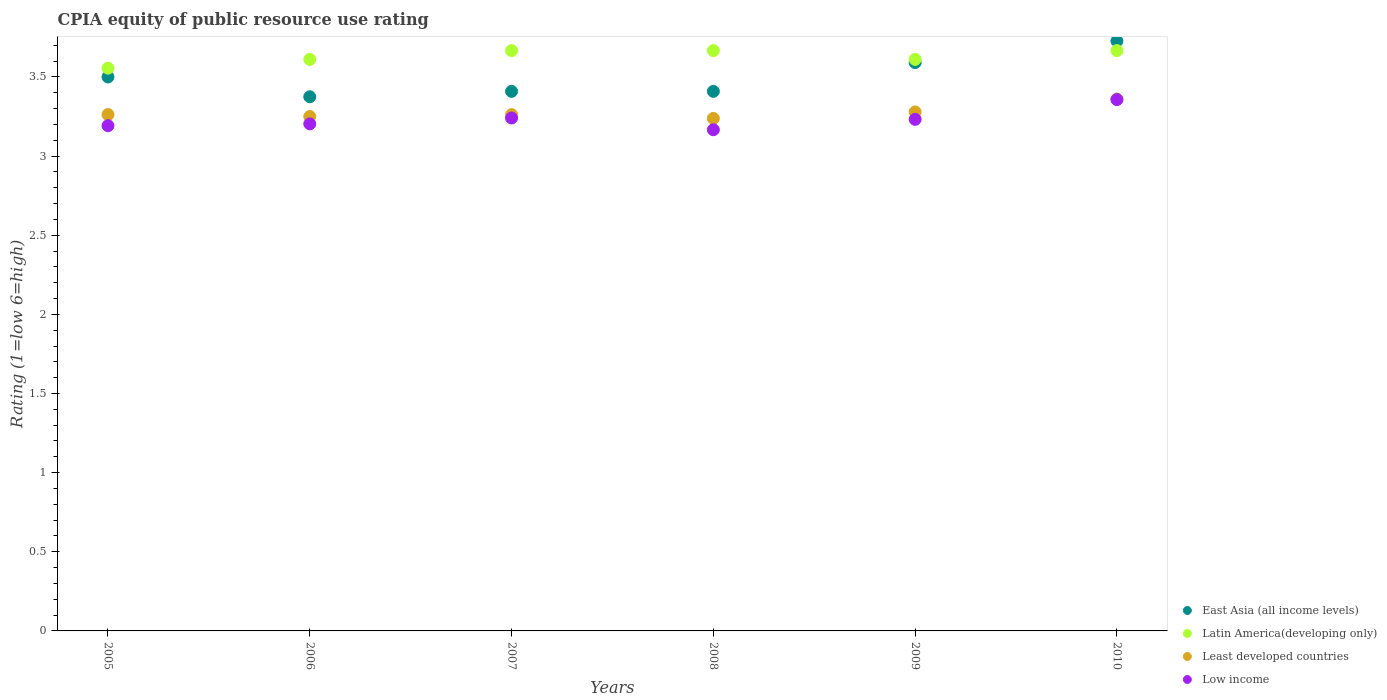How many different coloured dotlines are there?
Make the answer very short. 4. Is the number of dotlines equal to the number of legend labels?
Ensure brevity in your answer.  Yes. What is the CPIA rating in East Asia (all income levels) in 2006?
Provide a short and direct response. 3.38. Across all years, what is the maximum CPIA rating in East Asia (all income levels)?
Offer a very short reply. 3.73. Across all years, what is the minimum CPIA rating in Latin America(developing only)?
Ensure brevity in your answer.  3.56. What is the total CPIA rating in Least developed countries in the graph?
Provide a succinct answer. 19.65. What is the difference between the CPIA rating in Low income in 2006 and that in 2010?
Your answer should be very brief. -0.15. What is the difference between the CPIA rating in Low income in 2009 and the CPIA rating in East Asia (all income levels) in 2008?
Your response must be concise. -0.18. What is the average CPIA rating in East Asia (all income levels) per year?
Your answer should be very brief. 3.5. In the year 2007, what is the difference between the CPIA rating in Least developed countries and CPIA rating in Latin America(developing only)?
Offer a terse response. -0.4. In how many years, is the CPIA rating in East Asia (all income levels) greater than 1.3?
Make the answer very short. 6. What is the ratio of the CPIA rating in East Asia (all income levels) in 2006 to that in 2009?
Provide a short and direct response. 0.94. What is the difference between the highest and the second highest CPIA rating in Latin America(developing only)?
Make the answer very short. 0. What is the difference between the highest and the lowest CPIA rating in Least developed countries?
Provide a short and direct response. 0.12. Is it the case that in every year, the sum of the CPIA rating in East Asia (all income levels) and CPIA rating in Least developed countries  is greater than the CPIA rating in Low income?
Give a very brief answer. Yes. Is the CPIA rating in Least developed countries strictly greater than the CPIA rating in East Asia (all income levels) over the years?
Keep it short and to the point. No. What is the difference between two consecutive major ticks on the Y-axis?
Offer a very short reply. 0.5. Does the graph contain any zero values?
Your answer should be very brief. No. Does the graph contain grids?
Keep it short and to the point. No. Where does the legend appear in the graph?
Make the answer very short. Bottom right. How many legend labels are there?
Offer a very short reply. 4. How are the legend labels stacked?
Your answer should be compact. Vertical. What is the title of the graph?
Offer a very short reply. CPIA equity of public resource use rating. Does "Guinea-Bissau" appear as one of the legend labels in the graph?
Make the answer very short. No. What is the Rating (1=low 6=high) of East Asia (all income levels) in 2005?
Make the answer very short. 3.5. What is the Rating (1=low 6=high) in Latin America(developing only) in 2005?
Offer a very short reply. 3.56. What is the Rating (1=low 6=high) of Least developed countries in 2005?
Your answer should be compact. 3.26. What is the Rating (1=low 6=high) of Low income in 2005?
Your answer should be compact. 3.19. What is the Rating (1=low 6=high) of East Asia (all income levels) in 2006?
Keep it short and to the point. 3.38. What is the Rating (1=low 6=high) in Latin America(developing only) in 2006?
Provide a succinct answer. 3.61. What is the Rating (1=low 6=high) in Low income in 2006?
Give a very brief answer. 3.2. What is the Rating (1=low 6=high) of East Asia (all income levels) in 2007?
Your answer should be very brief. 3.41. What is the Rating (1=low 6=high) in Latin America(developing only) in 2007?
Provide a succinct answer. 3.67. What is the Rating (1=low 6=high) in Least developed countries in 2007?
Provide a succinct answer. 3.26. What is the Rating (1=low 6=high) of Low income in 2007?
Keep it short and to the point. 3.24. What is the Rating (1=low 6=high) of East Asia (all income levels) in 2008?
Provide a short and direct response. 3.41. What is the Rating (1=low 6=high) in Latin America(developing only) in 2008?
Your response must be concise. 3.67. What is the Rating (1=low 6=high) of Least developed countries in 2008?
Make the answer very short. 3.24. What is the Rating (1=low 6=high) in Low income in 2008?
Offer a terse response. 3.17. What is the Rating (1=low 6=high) in East Asia (all income levels) in 2009?
Give a very brief answer. 3.59. What is the Rating (1=low 6=high) in Latin America(developing only) in 2009?
Ensure brevity in your answer.  3.61. What is the Rating (1=low 6=high) of Least developed countries in 2009?
Offer a terse response. 3.28. What is the Rating (1=low 6=high) of Low income in 2009?
Keep it short and to the point. 3.23. What is the Rating (1=low 6=high) in East Asia (all income levels) in 2010?
Ensure brevity in your answer.  3.73. What is the Rating (1=low 6=high) in Latin America(developing only) in 2010?
Make the answer very short. 3.67. What is the Rating (1=low 6=high) of Least developed countries in 2010?
Your answer should be compact. 3.36. What is the Rating (1=low 6=high) of Low income in 2010?
Keep it short and to the point. 3.36. Across all years, what is the maximum Rating (1=low 6=high) in East Asia (all income levels)?
Provide a short and direct response. 3.73. Across all years, what is the maximum Rating (1=low 6=high) in Latin America(developing only)?
Offer a terse response. 3.67. Across all years, what is the maximum Rating (1=low 6=high) of Least developed countries?
Provide a succinct answer. 3.36. Across all years, what is the maximum Rating (1=low 6=high) in Low income?
Ensure brevity in your answer.  3.36. Across all years, what is the minimum Rating (1=low 6=high) of East Asia (all income levels)?
Offer a terse response. 3.38. Across all years, what is the minimum Rating (1=low 6=high) in Latin America(developing only)?
Give a very brief answer. 3.56. Across all years, what is the minimum Rating (1=low 6=high) of Least developed countries?
Ensure brevity in your answer.  3.24. Across all years, what is the minimum Rating (1=low 6=high) of Low income?
Make the answer very short. 3.17. What is the total Rating (1=low 6=high) of East Asia (all income levels) in the graph?
Provide a short and direct response. 21.01. What is the total Rating (1=low 6=high) of Latin America(developing only) in the graph?
Your answer should be compact. 21.78. What is the total Rating (1=low 6=high) in Least developed countries in the graph?
Your answer should be compact. 19.65. What is the total Rating (1=low 6=high) of Low income in the graph?
Provide a succinct answer. 19.39. What is the difference between the Rating (1=low 6=high) of Latin America(developing only) in 2005 and that in 2006?
Your response must be concise. -0.06. What is the difference between the Rating (1=low 6=high) of Least developed countries in 2005 and that in 2006?
Offer a very short reply. 0.01. What is the difference between the Rating (1=low 6=high) in Low income in 2005 and that in 2006?
Provide a short and direct response. -0.01. What is the difference between the Rating (1=low 6=high) of East Asia (all income levels) in 2005 and that in 2007?
Your response must be concise. 0.09. What is the difference between the Rating (1=low 6=high) in Latin America(developing only) in 2005 and that in 2007?
Your answer should be very brief. -0.11. What is the difference between the Rating (1=low 6=high) in Least developed countries in 2005 and that in 2007?
Offer a very short reply. 0. What is the difference between the Rating (1=low 6=high) of Low income in 2005 and that in 2007?
Give a very brief answer. -0.05. What is the difference between the Rating (1=low 6=high) in East Asia (all income levels) in 2005 and that in 2008?
Keep it short and to the point. 0.09. What is the difference between the Rating (1=low 6=high) of Latin America(developing only) in 2005 and that in 2008?
Ensure brevity in your answer.  -0.11. What is the difference between the Rating (1=low 6=high) in Least developed countries in 2005 and that in 2008?
Provide a short and direct response. 0.02. What is the difference between the Rating (1=low 6=high) in Low income in 2005 and that in 2008?
Your response must be concise. 0.03. What is the difference between the Rating (1=low 6=high) in East Asia (all income levels) in 2005 and that in 2009?
Offer a very short reply. -0.09. What is the difference between the Rating (1=low 6=high) of Latin America(developing only) in 2005 and that in 2009?
Ensure brevity in your answer.  -0.06. What is the difference between the Rating (1=low 6=high) in Least developed countries in 2005 and that in 2009?
Ensure brevity in your answer.  -0.02. What is the difference between the Rating (1=low 6=high) of Low income in 2005 and that in 2009?
Your response must be concise. -0.04. What is the difference between the Rating (1=low 6=high) of East Asia (all income levels) in 2005 and that in 2010?
Your answer should be compact. -0.23. What is the difference between the Rating (1=low 6=high) in Latin America(developing only) in 2005 and that in 2010?
Offer a very short reply. -0.11. What is the difference between the Rating (1=low 6=high) in Least developed countries in 2005 and that in 2010?
Provide a short and direct response. -0.1. What is the difference between the Rating (1=low 6=high) in Low income in 2005 and that in 2010?
Your answer should be compact. -0.16. What is the difference between the Rating (1=low 6=high) in East Asia (all income levels) in 2006 and that in 2007?
Your response must be concise. -0.03. What is the difference between the Rating (1=low 6=high) in Latin America(developing only) in 2006 and that in 2007?
Your response must be concise. -0.06. What is the difference between the Rating (1=low 6=high) of Least developed countries in 2006 and that in 2007?
Your response must be concise. -0.01. What is the difference between the Rating (1=low 6=high) of Low income in 2006 and that in 2007?
Make the answer very short. -0.04. What is the difference between the Rating (1=low 6=high) in East Asia (all income levels) in 2006 and that in 2008?
Offer a terse response. -0.03. What is the difference between the Rating (1=low 6=high) in Latin America(developing only) in 2006 and that in 2008?
Keep it short and to the point. -0.06. What is the difference between the Rating (1=low 6=high) in Least developed countries in 2006 and that in 2008?
Offer a very short reply. 0.01. What is the difference between the Rating (1=low 6=high) in Low income in 2006 and that in 2008?
Your answer should be very brief. 0.04. What is the difference between the Rating (1=low 6=high) in East Asia (all income levels) in 2006 and that in 2009?
Offer a very short reply. -0.22. What is the difference between the Rating (1=low 6=high) of Least developed countries in 2006 and that in 2009?
Offer a very short reply. -0.03. What is the difference between the Rating (1=low 6=high) of Low income in 2006 and that in 2009?
Offer a very short reply. -0.03. What is the difference between the Rating (1=low 6=high) of East Asia (all income levels) in 2006 and that in 2010?
Offer a very short reply. -0.35. What is the difference between the Rating (1=low 6=high) of Latin America(developing only) in 2006 and that in 2010?
Your answer should be very brief. -0.06. What is the difference between the Rating (1=low 6=high) of Least developed countries in 2006 and that in 2010?
Ensure brevity in your answer.  -0.11. What is the difference between the Rating (1=low 6=high) in Low income in 2006 and that in 2010?
Your answer should be compact. -0.15. What is the difference between the Rating (1=low 6=high) in Least developed countries in 2007 and that in 2008?
Keep it short and to the point. 0.02. What is the difference between the Rating (1=low 6=high) in Low income in 2007 and that in 2008?
Provide a succinct answer. 0.07. What is the difference between the Rating (1=low 6=high) in East Asia (all income levels) in 2007 and that in 2009?
Your answer should be very brief. -0.18. What is the difference between the Rating (1=low 6=high) of Latin America(developing only) in 2007 and that in 2009?
Make the answer very short. 0.06. What is the difference between the Rating (1=low 6=high) of Least developed countries in 2007 and that in 2009?
Offer a very short reply. -0.02. What is the difference between the Rating (1=low 6=high) of Low income in 2007 and that in 2009?
Provide a short and direct response. 0.01. What is the difference between the Rating (1=low 6=high) of East Asia (all income levels) in 2007 and that in 2010?
Make the answer very short. -0.32. What is the difference between the Rating (1=low 6=high) of Least developed countries in 2007 and that in 2010?
Offer a very short reply. -0.1. What is the difference between the Rating (1=low 6=high) of Low income in 2007 and that in 2010?
Make the answer very short. -0.12. What is the difference between the Rating (1=low 6=high) of East Asia (all income levels) in 2008 and that in 2009?
Your answer should be compact. -0.18. What is the difference between the Rating (1=low 6=high) of Latin America(developing only) in 2008 and that in 2009?
Make the answer very short. 0.06. What is the difference between the Rating (1=low 6=high) in Least developed countries in 2008 and that in 2009?
Your response must be concise. -0.04. What is the difference between the Rating (1=low 6=high) in Low income in 2008 and that in 2009?
Make the answer very short. -0.07. What is the difference between the Rating (1=low 6=high) in East Asia (all income levels) in 2008 and that in 2010?
Ensure brevity in your answer.  -0.32. What is the difference between the Rating (1=low 6=high) of Latin America(developing only) in 2008 and that in 2010?
Ensure brevity in your answer.  0. What is the difference between the Rating (1=low 6=high) in Least developed countries in 2008 and that in 2010?
Offer a terse response. -0.12. What is the difference between the Rating (1=low 6=high) in Low income in 2008 and that in 2010?
Ensure brevity in your answer.  -0.19. What is the difference between the Rating (1=low 6=high) of East Asia (all income levels) in 2009 and that in 2010?
Ensure brevity in your answer.  -0.14. What is the difference between the Rating (1=low 6=high) of Latin America(developing only) in 2009 and that in 2010?
Provide a short and direct response. -0.06. What is the difference between the Rating (1=low 6=high) in Least developed countries in 2009 and that in 2010?
Provide a succinct answer. -0.08. What is the difference between the Rating (1=low 6=high) of Low income in 2009 and that in 2010?
Your response must be concise. -0.12. What is the difference between the Rating (1=low 6=high) of East Asia (all income levels) in 2005 and the Rating (1=low 6=high) of Latin America(developing only) in 2006?
Your answer should be compact. -0.11. What is the difference between the Rating (1=low 6=high) of East Asia (all income levels) in 2005 and the Rating (1=low 6=high) of Low income in 2006?
Ensure brevity in your answer.  0.3. What is the difference between the Rating (1=low 6=high) of Latin America(developing only) in 2005 and the Rating (1=low 6=high) of Least developed countries in 2006?
Ensure brevity in your answer.  0.31. What is the difference between the Rating (1=low 6=high) in Latin America(developing only) in 2005 and the Rating (1=low 6=high) in Low income in 2006?
Make the answer very short. 0.35. What is the difference between the Rating (1=low 6=high) in Least developed countries in 2005 and the Rating (1=low 6=high) in Low income in 2006?
Offer a terse response. 0.06. What is the difference between the Rating (1=low 6=high) in East Asia (all income levels) in 2005 and the Rating (1=low 6=high) in Latin America(developing only) in 2007?
Keep it short and to the point. -0.17. What is the difference between the Rating (1=low 6=high) of East Asia (all income levels) in 2005 and the Rating (1=low 6=high) of Least developed countries in 2007?
Give a very brief answer. 0.24. What is the difference between the Rating (1=low 6=high) of East Asia (all income levels) in 2005 and the Rating (1=low 6=high) of Low income in 2007?
Ensure brevity in your answer.  0.26. What is the difference between the Rating (1=low 6=high) of Latin America(developing only) in 2005 and the Rating (1=low 6=high) of Least developed countries in 2007?
Provide a short and direct response. 0.29. What is the difference between the Rating (1=low 6=high) in Latin America(developing only) in 2005 and the Rating (1=low 6=high) in Low income in 2007?
Offer a very short reply. 0.31. What is the difference between the Rating (1=low 6=high) of Least developed countries in 2005 and the Rating (1=low 6=high) of Low income in 2007?
Provide a succinct answer. 0.02. What is the difference between the Rating (1=low 6=high) of East Asia (all income levels) in 2005 and the Rating (1=low 6=high) of Latin America(developing only) in 2008?
Offer a terse response. -0.17. What is the difference between the Rating (1=low 6=high) in East Asia (all income levels) in 2005 and the Rating (1=low 6=high) in Least developed countries in 2008?
Offer a very short reply. 0.26. What is the difference between the Rating (1=low 6=high) of East Asia (all income levels) in 2005 and the Rating (1=low 6=high) of Low income in 2008?
Keep it short and to the point. 0.33. What is the difference between the Rating (1=low 6=high) in Latin America(developing only) in 2005 and the Rating (1=low 6=high) in Least developed countries in 2008?
Make the answer very short. 0.32. What is the difference between the Rating (1=low 6=high) of Latin America(developing only) in 2005 and the Rating (1=low 6=high) of Low income in 2008?
Your response must be concise. 0.39. What is the difference between the Rating (1=low 6=high) of Least developed countries in 2005 and the Rating (1=low 6=high) of Low income in 2008?
Ensure brevity in your answer.  0.1. What is the difference between the Rating (1=low 6=high) of East Asia (all income levels) in 2005 and the Rating (1=low 6=high) of Latin America(developing only) in 2009?
Ensure brevity in your answer.  -0.11. What is the difference between the Rating (1=low 6=high) in East Asia (all income levels) in 2005 and the Rating (1=low 6=high) in Least developed countries in 2009?
Ensure brevity in your answer.  0.22. What is the difference between the Rating (1=low 6=high) of East Asia (all income levels) in 2005 and the Rating (1=low 6=high) of Low income in 2009?
Your answer should be very brief. 0.27. What is the difference between the Rating (1=low 6=high) of Latin America(developing only) in 2005 and the Rating (1=low 6=high) of Least developed countries in 2009?
Give a very brief answer. 0.28. What is the difference between the Rating (1=low 6=high) in Latin America(developing only) in 2005 and the Rating (1=low 6=high) in Low income in 2009?
Ensure brevity in your answer.  0.32. What is the difference between the Rating (1=low 6=high) of Least developed countries in 2005 and the Rating (1=low 6=high) of Low income in 2009?
Your answer should be compact. 0.03. What is the difference between the Rating (1=low 6=high) in East Asia (all income levels) in 2005 and the Rating (1=low 6=high) in Least developed countries in 2010?
Your answer should be very brief. 0.14. What is the difference between the Rating (1=low 6=high) in East Asia (all income levels) in 2005 and the Rating (1=low 6=high) in Low income in 2010?
Make the answer very short. 0.14. What is the difference between the Rating (1=low 6=high) of Latin America(developing only) in 2005 and the Rating (1=low 6=high) of Least developed countries in 2010?
Your answer should be compact. 0.2. What is the difference between the Rating (1=low 6=high) in Latin America(developing only) in 2005 and the Rating (1=low 6=high) in Low income in 2010?
Ensure brevity in your answer.  0.2. What is the difference between the Rating (1=low 6=high) of Least developed countries in 2005 and the Rating (1=low 6=high) of Low income in 2010?
Ensure brevity in your answer.  -0.09. What is the difference between the Rating (1=low 6=high) in East Asia (all income levels) in 2006 and the Rating (1=low 6=high) in Latin America(developing only) in 2007?
Your response must be concise. -0.29. What is the difference between the Rating (1=low 6=high) of East Asia (all income levels) in 2006 and the Rating (1=low 6=high) of Least developed countries in 2007?
Offer a very short reply. 0.11. What is the difference between the Rating (1=low 6=high) in East Asia (all income levels) in 2006 and the Rating (1=low 6=high) in Low income in 2007?
Your answer should be compact. 0.13. What is the difference between the Rating (1=low 6=high) of Latin America(developing only) in 2006 and the Rating (1=low 6=high) of Least developed countries in 2007?
Make the answer very short. 0.35. What is the difference between the Rating (1=low 6=high) in Latin America(developing only) in 2006 and the Rating (1=low 6=high) in Low income in 2007?
Give a very brief answer. 0.37. What is the difference between the Rating (1=low 6=high) in Least developed countries in 2006 and the Rating (1=low 6=high) in Low income in 2007?
Give a very brief answer. 0.01. What is the difference between the Rating (1=low 6=high) of East Asia (all income levels) in 2006 and the Rating (1=low 6=high) of Latin America(developing only) in 2008?
Offer a terse response. -0.29. What is the difference between the Rating (1=low 6=high) in East Asia (all income levels) in 2006 and the Rating (1=low 6=high) in Least developed countries in 2008?
Make the answer very short. 0.14. What is the difference between the Rating (1=low 6=high) of East Asia (all income levels) in 2006 and the Rating (1=low 6=high) of Low income in 2008?
Make the answer very short. 0.21. What is the difference between the Rating (1=low 6=high) in Latin America(developing only) in 2006 and the Rating (1=low 6=high) in Least developed countries in 2008?
Provide a succinct answer. 0.37. What is the difference between the Rating (1=low 6=high) in Latin America(developing only) in 2006 and the Rating (1=low 6=high) in Low income in 2008?
Offer a very short reply. 0.44. What is the difference between the Rating (1=low 6=high) in Least developed countries in 2006 and the Rating (1=low 6=high) in Low income in 2008?
Ensure brevity in your answer.  0.08. What is the difference between the Rating (1=low 6=high) of East Asia (all income levels) in 2006 and the Rating (1=low 6=high) of Latin America(developing only) in 2009?
Your answer should be compact. -0.24. What is the difference between the Rating (1=low 6=high) of East Asia (all income levels) in 2006 and the Rating (1=low 6=high) of Least developed countries in 2009?
Your answer should be compact. 0.1. What is the difference between the Rating (1=low 6=high) in East Asia (all income levels) in 2006 and the Rating (1=low 6=high) in Low income in 2009?
Offer a very short reply. 0.14. What is the difference between the Rating (1=low 6=high) in Latin America(developing only) in 2006 and the Rating (1=low 6=high) in Least developed countries in 2009?
Keep it short and to the point. 0.33. What is the difference between the Rating (1=low 6=high) of Latin America(developing only) in 2006 and the Rating (1=low 6=high) of Low income in 2009?
Give a very brief answer. 0.38. What is the difference between the Rating (1=low 6=high) of Least developed countries in 2006 and the Rating (1=low 6=high) of Low income in 2009?
Offer a very short reply. 0.02. What is the difference between the Rating (1=low 6=high) of East Asia (all income levels) in 2006 and the Rating (1=low 6=high) of Latin America(developing only) in 2010?
Provide a short and direct response. -0.29. What is the difference between the Rating (1=low 6=high) in East Asia (all income levels) in 2006 and the Rating (1=low 6=high) in Least developed countries in 2010?
Make the answer very short. 0.01. What is the difference between the Rating (1=low 6=high) of East Asia (all income levels) in 2006 and the Rating (1=low 6=high) of Low income in 2010?
Offer a very short reply. 0.02. What is the difference between the Rating (1=low 6=high) of Latin America(developing only) in 2006 and the Rating (1=low 6=high) of Least developed countries in 2010?
Provide a succinct answer. 0.25. What is the difference between the Rating (1=low 6=high) of Latin America(developing only) in 2006 and the Rating (1=low 6=high) of Low income in 2010?
Give a very brief answer. 0.25. What is the difference between the Rating (1=low 6=high) of Least developed countries in 2006 and the Rating (1=low 6=high) of Low income in 2010?
Provide a short and direct response. -0.11. What is the difference between the Rating (1=low 6=high) of East Asia (all income levels) in 2007 and the Rating (1=low 6=high) of Latin America(developing only) in 2008?
Your answer should be very brief. -0.26. What is the difference between the Rating (1=low 6=high) in East Asia (all income levels) in 2007 and the Rating (1=low 6=high) in Least developed countries in 2008?
Offer a very short reply. 0.17. What is the difference between the Rating (1=low 6=high) of East Asia (all income levels) in 2007 and the Rating (1=low 6=high) of Low income in 2008?
Your answer should be compact. 0.24. What is the difference between the Rating (1=low 6=high) of Latin America(developing only) in 2007 and the Rating (1=low 6=high) of Least developed countries in 2008?
Give a very brief answer. 0.43. What is the difference between the Rating (1=low 6=high) in Latin America(developing only) in 2007 and the Rating (1=low 6=high) in Low income in 2008?
Keep it short and to the point. 0.5. What is the difference between the Rating (1=low 6=high) of Least developed countries in 2007 and the Rating (1=low 6=high) of Low income in 2008?
Provide a succinct answer. 0.1. What is the difference between the Rating (1=low 6=high) of East Asia (all income levels) in 2007 and the Rating (1=low 6=high) of Latin America(developing only) in 2009?
Your answer should be compact. -0.2. What is the difference between the Rating (1=low 6=high) of East Asia (all income levels) in 2007 and the Rating (1=low 6=high) of Least developed countries in 2009?
Your response must be concise. 0.13. What is the difference between the Rating (1=low 6=high) in East Asia (all income levels) in 2007 and the Rating (1=low 6=high) in Low income in 2009?
Provide a short and direct response. 0.18. What is the difference between the Rating (1=low 6=high) of Latin America(developing only) in 2007 and the Rating (1=low 6=high) of Least developed countries in 2009?
Ensure brevity in your answer.  0.39. What is the difference between the Rating (1=low 6=high) in Latin America(developing only) in 2007 and the Rating (1=low 6=high) in Low income in 2009?
Offer a terse response. 0.43. What is the difference between the Rating (1=low 6=high) in Least developed countries in 2007 and the Rating (1=low 6=high) in Low income in 2009?
Give a very brief answer. 0.03. What is the difference between the Rating (1=low 6=high) in East Asia (all income levels) in 2007 and the Rating (1=low 6=high) in Latin America(developing only) in 2010?
Offer a terse response. -0.26. What is the difference between the Rating (1=low 6=high) in East Asia (all income levels) in 2007 and the Rating (1=low 6=high) in Least developed countries in 2010?
Give a very brief answer. 0.05. What is the difference between the Rating (1=low 6=high) of East Asia (all income levels) in 2007 and the Rating (1=low 6=high) of Low income in 2010?
Give a very brief answer. 0.05. What is the difference between the Rating (1=low 6=high) of Latin America(developing only) in 2007 and the Rating (1=low 6=high) of Least developed countries in 2010?
Make the answer very short. 0.31. What is the difference between the Rating (1=low 6=high) in Latin America(developing only) in 2007 and the Rating (1=low 6=high) in Low income in 2010?
Ensure brevity in your answer.  0.31. What is the difference between the Rating (1=low 6=high) of Least developed countries in 2007 and the Rating (1=low 6=high) of Low income in 2010?
Provide a short and direct response. -0.1. What is the difference between the Rating (1=low 6=high) of East Asia (all income levels) in 2008 and the Rating (1=low 6=high) of Latin America(developing only) in 2009?
Your answer should be very brief. -0.2. What is the difference between the Rating (1=low 6=high) of East Asia (all income levels) in 2008 and the Rating (1=low 6=high) of Least developed countries in 2009?
Give a very brief answer. 0.13. What is the difference between the Rating (1=low 6=high) of East Asia (all income levels) in 2008 and the Rating (1=low 6=high) of Low income in 2009?
Provide a succinct answer. 0.18. What is the difference between the Rating (1=low 6=high) in Latin America(developing only) in 2008 and the Rating (1=low 6=high) in Least developed countries in 2009?
Offer a terse response. 0.39. What is the difference between the Rating (1=low 6=high) in Latin America(developing only) in 2008 and the Rating (1=low 6=high) in Low income in 2009?
Your answer should be very brief. 0.43. What is the difference between the Rating (1=low 6=high) of Least developed countries in 2008 and the Rating (1=low 6=high) of Low income in 2009?
Provide a short and direct response. 0.01. What is the difference between the Rating (1=low 6=high) in East Asia (all income levels) in 2008 and the Rating (1=low 6=high) in Latin America(developing only) in 2010?
Ensure brevity in your answer.  -0.26. What is the difference between the Rating (1=low 6=high) of East Asia (all income levels) in 2008 and the Rating (1=low 6=high) of Least developed countries in 2010?
Provide a short and direct response. 0.05. What is the difference between the Rating (1=low 6=high) of East Asia (all income levels) in 2008 and the Rating (1=low 6=high) of Low income in 2010?
Keep it short and to the point. 0.05. What is the difference between the Rating (1=low 6=high) in Latin America(developing only) in 2008 and the Rating (1=low 6=high) in Least developed countries in 2010?
Your response must be concise. 0.31. What is the difference between the Rating (1=low 6=high) in Latin America(developing only) in 2008 and the Rating (1=low 6=high) in Low income in 2010?
Your answer should be compact. 0.31. What is the difference between the Rating (1=low 6=high) of Least developed countries in 2008 and the Rating (1=low 6=high) of Low income in 2010?
Ensure brevity in your answer.  -0.12. What is the difference between the Rating (1=low 6=high) in East Asia (all income levels) in 2009 and the Rating (1=low 6=high) in Latin America(developing only) in 2010?
Keep it short and to the point. -0.08. What is the difference between the Rating (1=low 6=high) of East Asia (all income levels) in 2009 and the Rating (1=low 6=high) of Least developed countries in 2010?
Your answer should be very brief. 0.23. What is the difference between the Rating (1=low 6=high) of East Asia (all income levels) in 2009 and the Rating (1=low 6=high) of Low income in 2010?
Keep it short and to the point. 0.23. What is the difference between the Rating (1=low 6=high) of Latin America(developing only) in 2009 and the Rating (1=low 6=high) of Least developed countries in 2010?
Your response must be concise. 0.25. What is the difference between the Rating (1=low 6=high) of Latin America(developing only) in 2009 and the Rating (1=low 6=high) of Low income in 2010?
Ensure brevity in your answer.  0.25. What is the difference between the Rating (1=low 6=high) of Least developed countries in 2009 and the Rating (1=low 6=high) of Low income in 2010?
Offer a terse response. -0.08. What is the average Rating (1=low 6=high) in East Asia (all income levels) per year?
Offer a terse response. 3.5. What is the average Rating (1=low 6=high) in Latin America(developing only) per year?
Give a very brief answer. 3.63. What is the average Rating (1=low 6=high) in Least developed countries per year?
Provide a short and direct response. 3.28. What is the average Rating (1=low 6=high) in Low income per year?
Make the answer very short. 3.23. In the year 2005, what is the difference between the Rating (1=low 6=high) of East Asia (all income levels) and Rating (1=low 6=high) of Latin America(developing only)?
Provide a short and direct response. -0.06. In the year 2005, what is the difference between the Rating (1=low 6=high) in East Asia (all income levels) and Rating (1=low 6=high) in Least developed countries?
Give a very brief answer. 0.24. In the year 2005, what is the difference between the Rating (1=low 6=high) of East Asia (all income levels) and Rating (1=low 6=high) of Low income?
Offer a terse response. 0.31. In the year 2005, what is the difference between the Rating (1=low 6=high) of Latin America(developing only) and Rating (1=low 6=high) of Least developed countries?
Your answer should be compact. 0.29. In the year 2005, what is the difference between the Rating (1=low 6=high) in Latin America(developing only) and Rating (1=low 6=high) in Low income?
Offer a terse response. 0.36. In the year 2005, what is the difference between the Rating (1=low 6=high) of Least developed countries and Rating (1=low 6=high) of Low income?
Give a very brief answer. 0.07. In the year 2006, what is the difference between the Rating (1=low 6=high) in East Asia (all income levels) and Rating (1=low 6=high) in Latin America(developing only)?
Ensure brevity in your answer.  -0.24. In the year 2006, what is the difference between the Rating (1=low 6=high) of East Asia (all income levels) and Rating (1=low 6=high) of Low income?
Offer a very short reply. 0.17. In the year 2006, what is the difference between the Rating (1=low 6=high) in Latin America(developing only) and Rating (1=low 6=high) in Least developed countries?
Give a very brief answer. 0.36. In the year 2006, what is the difference between the Rating (1=low 6=high) in Latin America(developing only) and Rating (1=low 6=high) in Low income?
Ensure brevity in your answer.  0.41. In the year 2006, what is the difference between the Rating (1=low 6=high) of Least developed countries and Rating (1=low 6=high) of Low income?
Keep it short and to the point. 0.05. In the year 2007, what is the difference between the Rating (1=low 6=high) of East Asia (all income levels) and Rating (1=low 6=high) of Latin America(developing only)?
Provide a short and direct response. -0.26. In the year 2007, what is the difference between the Rating (1=low 6=high) of East Asia (all income levels) and Rating (1=low 6=high) of Least developed countries?
Make the answer very short. 0.15. In the year 2007, what is the difference between the Rating (1=low 6=high) of East Asia (all income levels) and Rating (1=low 6=high) of Low income?
Give a very brief answer. 0.17. In the year 2007, what is the difference between the Rating (1=low 6=high) of Latin America(developing only) and Rating (1=low 6=high) of Least developed countries?
Offer a very short reply. 0.4. In the year 2007, what is the difference between the Rating (1=low 6=high) of Latin America(developing only) and Rating (1=low 6=high) of Low income?
Keep it short and to the point. 0.43. In the year 2007, what is the difference between the Rating (1=low 6=high) of Least developed countries and Rating (1=low 6=high) of Low income?
Offer a very short reply. 0.02. In the year 2008, what is the difference between the Rating (1=low 6=high) of East Asia (all income levels) and Rating (1=low 6=high) of Latin America(developing only)?
Your response must be concise. -0.26. In the year 2008, what is the difference between the Rating (1=low 6=high) of East Asia (all income levels) and Rating (1=low 6=high) of Least developed countries?
Give a very brief answer. 0.17. In the year 2008, what is the difference between the Rating (1=low 6=high) of East Asia (all income levels) and Rating (1=low 6=high) of Low income?
Your answer should be compact. 0.24. In the year 2008, what is the difference between the Rating (1=low 6=high) in Latin America(developing only) and Rating (1=low 6=high) in Least developed countries?
Offer a very short reply. 0.43. In the year 2008, what is the difference between the Rating (1=low 6=high) in Latin America(developing only) and Rating (1=low 6=high) in Low income?
Ensure brevity in your answer.  0.5. In the year 2008, what is the difference between the Rating (1=low 6=high) in Least developed countries and Rating (1=low 6=high) in Low income?
Your response must be concise. 0.07. In the year 2009, what is the difference between the Rating (1=low 6=high) in East Asia (all income levels) and Rating (1=low 6=high) in Latin America(developing only)?
Offer a very short reply. -0.02. In the year 2009, what is the difference between the Rating (1=low 6=high) in East Asia (all income levels) and Rating (1=low 6=high) in Least developed countries?
Your response must be concise. 0.31. In the year 2009, what is the difference between the Rating (1=low 6=high) of East Asia (all income levels) and Rating (1=low 6=high) of Low income?
Ensure brevity in your answer.  0.36. In the year 2009, what is the difference between the Rating (1=low 6=high) of Latin America(developing only) and Rating (1=low 6=high) of Least developed countries?
Ensure brevity in your answer.  0.33. In the year 2009, what is the difference between the Rating (1=low 6=high) of Latin America(developing only) and Rating (1=low 6=high) of Low income?
Your answer should be compact. 0.38. In the year 2009, what is the difference between the Rating (1=low 6=high) of Least developed countries and Rating (1=low 6=high) of Low income?
Offer a terse response. 0.05. In the year 2010, what is the difference between the Rating (1=low 6=high) in East Asia (all income levels) and Rating (1=low 6=high) in Latin America(developing only)?
Make the answer very short. 0.06. In the year 2010, what is the difference between the Rating (1=low 6=high) of East Asia (all income levels) and Rating (1=low 6=high) of Least developed countries?
Your answer should be compact. 0.37. In the year 2010, what is the difference between the Rating (1=low 6=high) of East Asia (all income levels) and Rating (1=low 6=high) of Low income?
Provide a short and direct response. 0.37. In the year 2010, what is the difference between the Rating (1=low 6=high) of Latin America(developing only) and Rating (1=low 6=high) of Least developed countries?
Give a very brief answer. 0.31. In the year 2010, what is the difference between the Rating (1=low 6=high) of Latin America(developing only) and Rating (1=low 6=high) of Low income?
Make the answer very short. 0.31. In the year 2010, what is the difference between the Rating (1=low 6=high) in Least developed countries and Rating (1=low 6=high) in Low income?
Your answer should be very brief. 0. What is the ratio of the Rating (1=low 6=high) of East Asia (all income levels) in 2005 to that in 2006?
Provide a short and direct response. 1.04. What is the ratio of the Rating (1=low 6=high) of Latin America(developing only) in 2005 to that in 2006?
Keep it short and to the point. 0.98. What is the ratio of the Rating (1=low 6=high) in East Asia (all income levels) in 2005 to that in 2007?
Your response must be concise. 1.03. What is the ratio of the Rating (1=low 6=high) in Latin America(developing only) in 2005 to that in 2007?
Make the answer very short. 0.97. What is the ratio of the Rating (1=low 6=high) of Low income in 2005 to that in 2007?
Offer a very short reply. 0.99. What is the ratio of the Rating (1=low 6=high) of East Asia (all income levels) in 2005 to that in 2008?
Offer a terse response. 1.03. What is the ratio of the Rating (1=low 6=high) of Latin America(developing only) in 2005 to that in 2008?
Keep it short and to the point. 0.97. What is the ratio of the Rating (1=low 6=high) of Least developed countries in 2005 to that in 2008?
Give a very brief answer. 1.01. What is the ratio of the Rating (1=low 6=high) in East Asia (all income levels) in 2005 to that in 2009?
Your answer should be compact. 0.97. What is the ratio of the Rating (1=low 6=high) in Latin America(developing only) in 2005 to that in 2009?
Your response must be concise. 0.98. What is the ratio of the Rating (1=low 6=high) in Least developed countries in 2005 to that in 2009?
Provide a short and direct response. 0.99. What is the ratio of the Rating (1=low 6=high) of East Asia (all income levels) in 2005 to that in 2010?
Make the answer very short. 0.94. What is the ratio of the Rating (1=low 6=high) in Latin America(developing only) in 2005 to that in 2010?
Offer a terse response. 0.97. What is the ratio of the Rating (1=low 6=high) of Least developed countries in 2005 to that in 2010?
Your response must be concise. 0.97. What is the ratio of the Rating (1=low 6=high) of Low income in 2005 to that in 2010?
Ensure brevity in your answer.  0.95. What is the ratio of the Rating (1=low 6=high) in Latin America(developing only) in 2006 to that in 2007?
Keep it short and to the point. 0.98. What is the ratio of the Rating (1=low 6=high) in Least developed countries in 2006 to that in 2007?
Offer a terse response. 1. What is the ratio of the Rating (1=low 6=high) in Low income in 2006 to that in 2007?
Your response must be concise. 0.99. What is the ratio of the Rating (1=low 6=high) in Least developed countries in 2006 to that in 2008?
Your answer should be very brief. 1. What is the ratio of the Rating (1=low 6=high) in Low income in 2006 to that in 2008?
Give a very brief answer. 1.01. What is the ratio of the Rating (1=low 6=high) of East Asia (all income levels) in 2006 to that in 2009?
Offer a terse response. 0.94. What is the ratio of the Rating (1=low 6=high) in East Asia (all income levels) in 2006 to that in 2010?
Your answer should be compact. 0.91. What is the ratio of the Rating (1=low 6=high) in Least developed countries in 2006 to that in 2010?
Give a very brief answer. 0.97. What is the ratio of the Rating (1=low 6=high) in Low income in 2006 to that in 2010?
Ensure brevity in your answer.  0.95. What is the ratio of the Rating (1=low 6=high) in East Asia (all income levels) in 2007 to that in 2008?
Your response must be concise. 1. What is the ratio of the Rating (1=low 6=high) of Least developed countries in 2007 to that in 2008?
Make the answer very short. 1.01. What is the ratio of the Rating (1=low 6=high) in Low income in 2007 to that in 2008?
Give a very brief answer. 1.02. What is the ratio of the Rating (1=low 6=high) of East Asia (all income levels) in 2007 to that in 2009?
Offer a terse response. 0.95. What is the ratio of the Rating (1=low 6=high) in Latin America(developing only) in 2007 to that in 2009?
Your response must be concise. 1.02. What is the ratio of the Rating (1=low 6=high) of Least developed countries in 2007 to that in 2009?
Give a very brief answer. 0.99. What is the ratio of the Rating (1=low 6=high) of Low income in 2007 to that in 2009?
Offer a very short reply. 1. What is the ratio of the Rating (1=low 6=high) in East Asia (all income levels) in 2007 to that in 2010?
Offer a very short reply. 0.91. What is the ratio of the Rating (1=low 6=high) in Latin America(developing only) in 2007 to that in 2010?
Your answer should be compact. 1. What is the ratio of the Rating (1=low 6=high) of Least developed countries in 2007 to that in 2010?
Give a very brief answer. 0.97. What is the ratio of the Rating (1=low 6=high) in Low income in 2007 to that in 2010?
Make the answer very short. 0.97. What is the ratio of the Rating (1=low 6=high) in East Asia (all income levels) in 2008 to that in 2009?
Provide a short and direct response. 0.95. What is the ratio of the Rating (1=low 6=high) in Latin America(developing only) in 2008 to that in 2009?
Your answer should be very brief. 1.02. What is the ratio of the Rating (1=low 6=high) of Least developed countries in 2008 to that in 2009?
Provide a succinct answer. 0.99. What is the ratio of the Rating (1=low 6=high) of Low income in 2008 to that in 2009?
Offer a very short reply. 0.98. What is the ratio of the Rating (1=low 6=high) of East Asia (all income levels) in 2008 to that in 2010?
Your response must be concise. 0.91. What is the ratio of the Rating (1=low 6=high) in Least developed countries in 2008 to that in 2010?
Ensure brevity in your answer.  0.96. What is the ratio of the Rating (1=low 6=high) in Low income in 2008 to that in 2010?
Ensure brevity in your answer.  0.94. What is the ratio of the Rating (1=low 6=high) in East Asia (all income levels) in 2009 to that in 2010?
Provide a short and direct response. 0.96. What is the ratio of the Rating (1=low 6=high) of Latin America(developing only) in 2009 to that in 2010?
Provide a short and direct response. 0.98. What is the ratio of the Rating (1=low 6=high) of Least developed countries in 2009 to that in 2010?
Your response must be concise. 0.98. What is the ratio of the Rating (1=low 6=high) in Low income in 2009 to that in 2010?
Ensure brevity in your answer.  0.96. What is the difference between the highest and the second highest Rating (1=low 6=high) of East Asia (all income levels)?
Give a very brief answer. 0.14. What is the difference between the highest and the second highest Rating (1=low 6=high) of Least developed countries?
Your answer should be very brief. 0.08. What is the difference between the highest and the second highest Rating (1=low 6=high) of Low income?
Provide a short and direct response. 0.12. What is the difference between the highest and the lowest Rating (1=low 6=high) in East Asia (all income levels)?
Keep it short and to the point. 0.35. What is the difference between the highest and the lowest Rating (1=low 6=high) in Latin America(developing only)?
Keep it short and to the point. 0.11. What is the difference between the highest and the lowest Rating (1=low 6=high) of Least developed countries?
Your response must be concise. 0.12. What is the difference between the highest and the lowest Rating (1=low 6=high) of Low income?
Offer a very short reply. 0.19. 